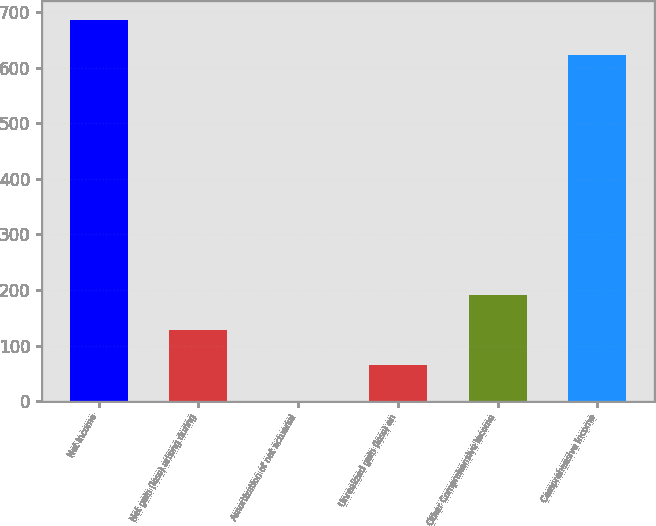<chart> <loc_0><loc_0><loc_500><loc_500><bar_chart><fcel>Net Income<fcel>Net gain (loss) arising during<fcel>Amortization of net actuarial<fcel>Unrealized gain (loss) on<fcel>Other Comprehensive Income<fcel>Comprehensive Income<nl><fcel>686.1<fcel>127.2<fcel>1<fcel>64.1<fcel>190.3<fcel>623<nl></chart> 